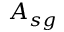Convert formula to latex. <formula><loc_0><loc_0><loc_500><loc_500>A _ { s g }</formula> 